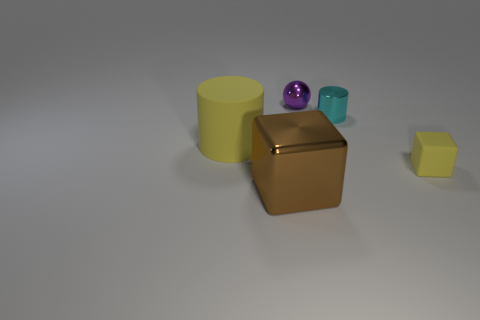Subtract all blocks. How many objects are left? 3 Add 4 small purple objects. How many objects exist? 9 Subtract all big blocks. Subtract all big yellow matte things. How many objects are left? 3 Add 1 tiny purple balls. How many tiny purple balls are left? 2 Add 1 tiny yellow objects. How many tiny yellow objects exist? 2 Subtract 1 purple spheres. How many objects are left? 4 